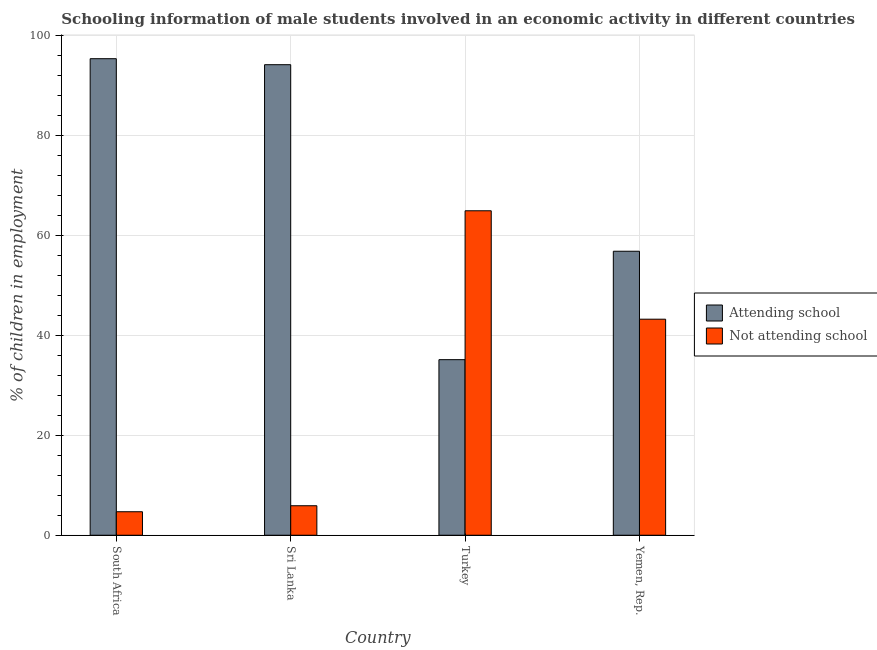How many groups of bars are there?
Your answer should be very brief. 4. Are the number of bars per tick equal to the number of legend labels?
Keep it short and to the point. Yes. Are the number of bars on each tick of the X-axis equal?
Provide a succinct answer. Yes. What is the label of the 3rd group of bars from the left?
Offer a very short reply. Turkey. What is the percentage of employed males who are attending school in Yemen, Rep.?
Keep it short and to the point. 56.8. Across all countries, what is the maximum percentage of employed males who are not attending school?
Keep it short and to the point. 64.89. Across all countries, what is the minimum percentage of employed males who are attending school?
Make the answer very short. 35.11. In which country was the percentage of employed males who are attending school maximum?
Offer a terse response. South Africa. In which country was the percentage of employed males who are not attending school minimum?
Your answer should be very brief. South Africa. What is the total percentage of employed males who are not attending school in the graph?
Provide a short and direct response. 118.69. What is the difference between the percentage of employed males who are not attending school in South Africa and that in Yemen, Rep.?
Give a very brief answer. -38.5. What is the difference between the percentage of employed males who are not attending school in South Africa and the percentage of employed males who are attending school in Turkey?
Keep it short and to the point. -30.41. What is the average percentage of employed males who are not attending school per country?
Your answer should be very brief. 29.67. What is the difference between the percentage of employed males who are not attending school and percentage of employed males who are attending school in Yemen, Rep.?
Give a very brief answer. -13.59. What is the ratio of the percentage of employed males who are not attending school in South Africa to that in Turkey?
Offer a terse response. 0.07. What is the difference between the highest and the second highest percentage of employed males who are attending school?
Your answer should be compact. 1.2. What is the difference between the highest and the lowest percentage of employed males who are attending school?
Offer a very short reply. 60.19. What does the 1st bar from the left in Turkey represents?
Offer a terse response. Attending school. What does the 1st bar from the right in Yemen, Rep. represents?
Your answer should be compact. Not attending school. Are all the bars in the graph horizontal?
Provide a succinct answer. No. Are the values on the major ticks of Y-axis written in scientific E-notation?
Your answer should be compact. No. Where does the legend appear in the graph?
Ensure brevity in your answer.  Center right. How many legend labels are there?
Offer a very short reply. 2. How are the legend labels stacked?
Keep it short and to the point. Vertical. What is the title of the graph?
Provide a short and direct response. Schooling information of male students involved in an economic activity in different countries. Does "Money lenders" appear as one of the legend labels in the graph?
Give a very brief answer. No. What is the label or title of the X-axis?
Offer a terse response. Country. What is the label or title of the Y-axis?
Offer a terse response. % of children in employment. What is the % of children in employment in Attending school in South Africa?
Give a very brief answer. 95.3. What is the % of children in employment in Attending school in Sri Lanka?
Your response must be concise. 94.1. What is the % of children in employment in Attending school in Turkey?
Keep it short and to the point. 35.11. What is the % of children in employment in Not attending school in Turkey?
Provide a short and direct response. 64.89. What is the % of children in employment in Attending school in Yemen, Rep.?
Offer a terse response. 56.8. What is the % of children in employment in Not attending school in Yemen, Rep.?
Offer a terse response. 43.2. Across all countries, what is the maximum % of children in employment in Attending school?
Your answer should be compact. 95.3. Across all countries, what is the maximum % of children in employment in Not attending school?
Ensure brevity in your answer.  64.89. Across all countries, what is the minimum % of children in employment in Attending school?
Provide a succinct answer. 35.11. What is the total % of children in employment in Attending school in the graph?
Ensure brevity in your answer.  281.31. What is the total % of children in employment of Not attending school in the graph?
Make the answer very short. 118.69. What is the difference between the % of children in employment in Attending school in South Africa and that in Turkey?
Your response must be concise. 60.19. What is the difference between the % of children in employment in Not attending school in South Africa and that in Turkey?
Offer a terse response. -60.19. What is the difference between the % of children in employment in Attending school in South Africa and that in Yemen, Rep.?
Keep it short and to the point. 38.5. What is the difference between the % of children in employment of Not attending school in South Africa and that in Yemen, Rep.?
Offer a very short reply. -38.5. What is the difference between the % of children in employment in Attending school in Sri Lanka and that in Turkey?
Your answer should be compact. 58.99. What is the difference between the % of children in employment of Not attending school in Sri Lanka and that in Turkey?
Your answer should be very brief. -58.99. What is the difference between the % of children in employment in Attending school in Sri Lanka and that in Yemen, Rep.?
Provide a succinct answer. 37.3. What is the difference between the % of children in employment of Not attending school in Sri Lanka and that in Yemen, Rep.?
Provide a succinct answer. -37.3. What is the difference between the % of children in employment of Attending school in Turkey and that in Yemen, Rep.?
Make the answer very short. -21.68. What is the difference between the % of children in employment in Not attending school in Turkey and that in Yemen, Rep.?
Ensure brevity in your answer.  21.68. What is the difference between the % of children in employment of Attending school in South Africa and the % of children in employment of Not attending school in Sri Lanka?
Your answer should be very brief. 89.4. What is the difference between the % of children in employment of Attending school in South Africa and the % of children in employment of Not attending school in Turkey?
Give a very brief answer. 30.41. What is the difference between the % of children in employment in Attending school in South Africa and the % of children in employment in Not attending school in Yemen, Rep.?
Your answer should be compact. 52.1. What is the difference between the % of children in employment of Attending school in Sri Lanka and the % of children in employment of Not attending school in Turkey?
Ensure brevity in your answer.  29.21. What is the difference between the % of children in employment of Attending school in Sri Lanka and the % of children in employment of Not attending school in Yemen, Rep.?
Make the answer very short. 50.9. What is the difference between the % of children in employment of Attending school in Turkey and the % of children in employment of Not attending school in Yemen, Rep.?
Your answer should be very brief. -8.09. What is the average % of children in employment of Attending school per country?
Ensure brevity in your answer.  70.33. What is the average % of children in employment in Not attending school per country?
Offer a terse response. 29.67. What is the difference between the % of children in employment in Attending school and % of children in employment in Not attending school in South Africa?
Ensure brevity in your answer.  90.6. What is the difference between the % of children in employment of Attending school and % of children in employment of Not attending school in Sri Lanka?
Provide a succinct answer. 88.2. What is the difference between the % of children in employment in Attending school and % of children in employment in Not attending school in Turkey?
Provide a short and direct response. -29.77. What is the difference between the % of children in employment of Attending school and % of children in employment of Not attending school in Yemen, Rep.?
Your response must be concise. 13.59. What is the ratio of the % of children in employment of Attending school in South Africa to that in Sri Lanka?
Provide a short and direct response. 1.01. What is the ratio of the % of children in employment of Not attending school in South Africa to that in Sri Lanka?
Provide a short and direct response. 0.8. What is the ratio of the % of children in employment in Attending school in South Africa to that in Turkey?
Offer a terse response. 2.71. What is the ratio of the % of children in employment of Not attending school in South Africa to that in Turkey?
Offer a very short reply. 0.07. What is the ratio of the % of children in employment in Attending school in South Africa to that in Yemen, Rep.?
Ensure brevity in your answer.  1.68. What is the ratio of the % of children in employment of Not attending school in South Africa to that in Yemen, Rep.?
Provide a short and direct response. 0.11. What is the ratio of the % of children in employment of Attending school in Sri Lanka to that in Turkey?
Your response must be concise. 2.68. What is the ratio of the % of children in employment of Not attending school in Sri Lanka to that in Turkey?
Keep it short and to the point. 0.09. What is the ratio of the % of children in employment in Attending school in Sri Lanka to that in Yemen, Rep.?
Ensure brevity in your answer.  1.66. What is the ratio of the % of children in employment of Not attending school in Sri Lanka to that in Yemen, Rep.?
Offer a terse response. 0.14. What is the ratio of the % of children in employment of Attending school in Turkey to that in Yemen, Rep.?
Ensure brevity in your answer.  0.62. What is the ratio of the % of children in employment in Not attending school in Turkey to that in Yemen, Rep.?
Keep it short and to the point. 1.5. What is the difference between the highest and the second highest % of children in employment of Not attending school?
Your answer should be very brief. 21.68. What is the difference between the highest and the lowest % of children in employment of Attending school?
Provide a succinct answer. 60.19. What is the difference between the highest and the lowest % of children in employment of Not attending school?
Make the answer very short. 60.19. 